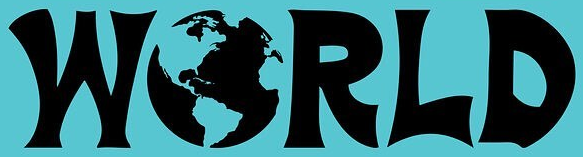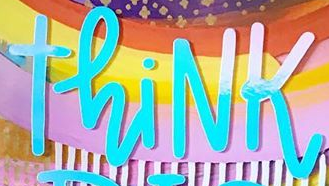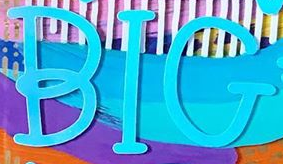What words are shown in these images in order, separated by a semicolon? WORLD; ThiNK; BIG 